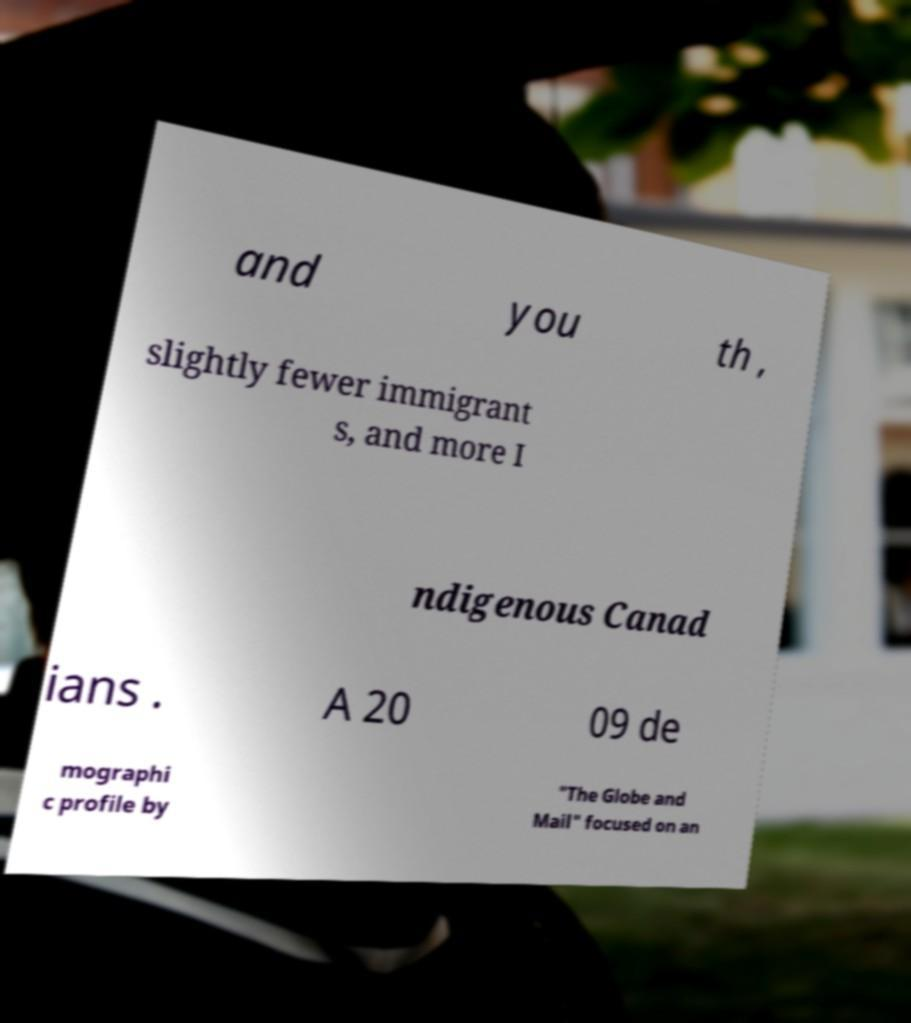For documentation purposes, I need the text within this image transcribed. Could you provide that? and you th , slightly fewer immigrant s, and more I ndigenous Canad ians . A 20 09 de mographi c profile by "The Globe and Mail" focused on an 